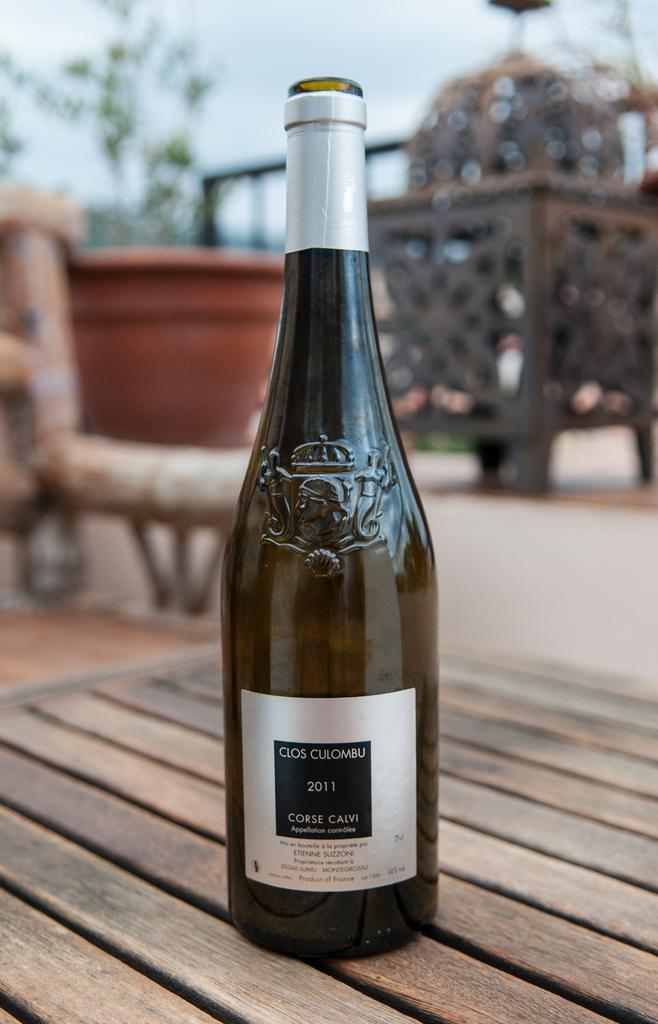<image>
Write a terse but informative summary of the picture. A bottle of wine with Clos Culumbo on it. 